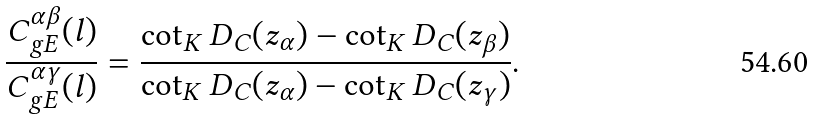<formula> <loc_0><loc_0><loc_500><loc_500>\frac { C ^ { \alpha \beta } _ { g E } ( l ) } { C ^ { \alpha \gamma } _ { g E } ( l ) } = \frac { \cot _ { K } D _ { C } ( z _ { \alpha } ) - \cot _ { K } D _ { C } ( z _ { \beta } ) } { \cot _ { K } D _ { C } ( z _ { \alpha } ) - \cot _ { K } D _ { C } ( z _ { \gamma } ) } .</formula> 